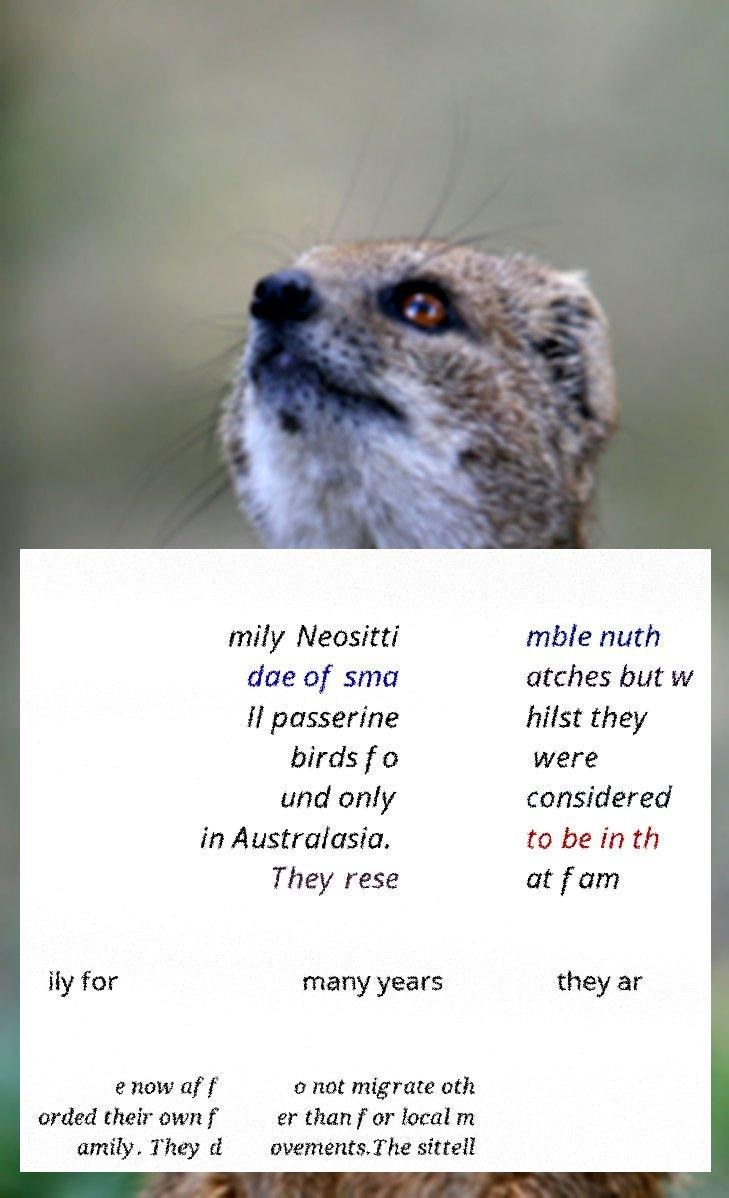I need the written content from this picture converted into text. Can you do that? mily Neositti dae of sma ll passerine birds fo und only in Australasia. They rese mble nuth atches but w hilst they were considered to be in th at fam ily for many years they ar e now aff orded their own f amily. They d o not migrate oth er than for local m ovements.The sittell 